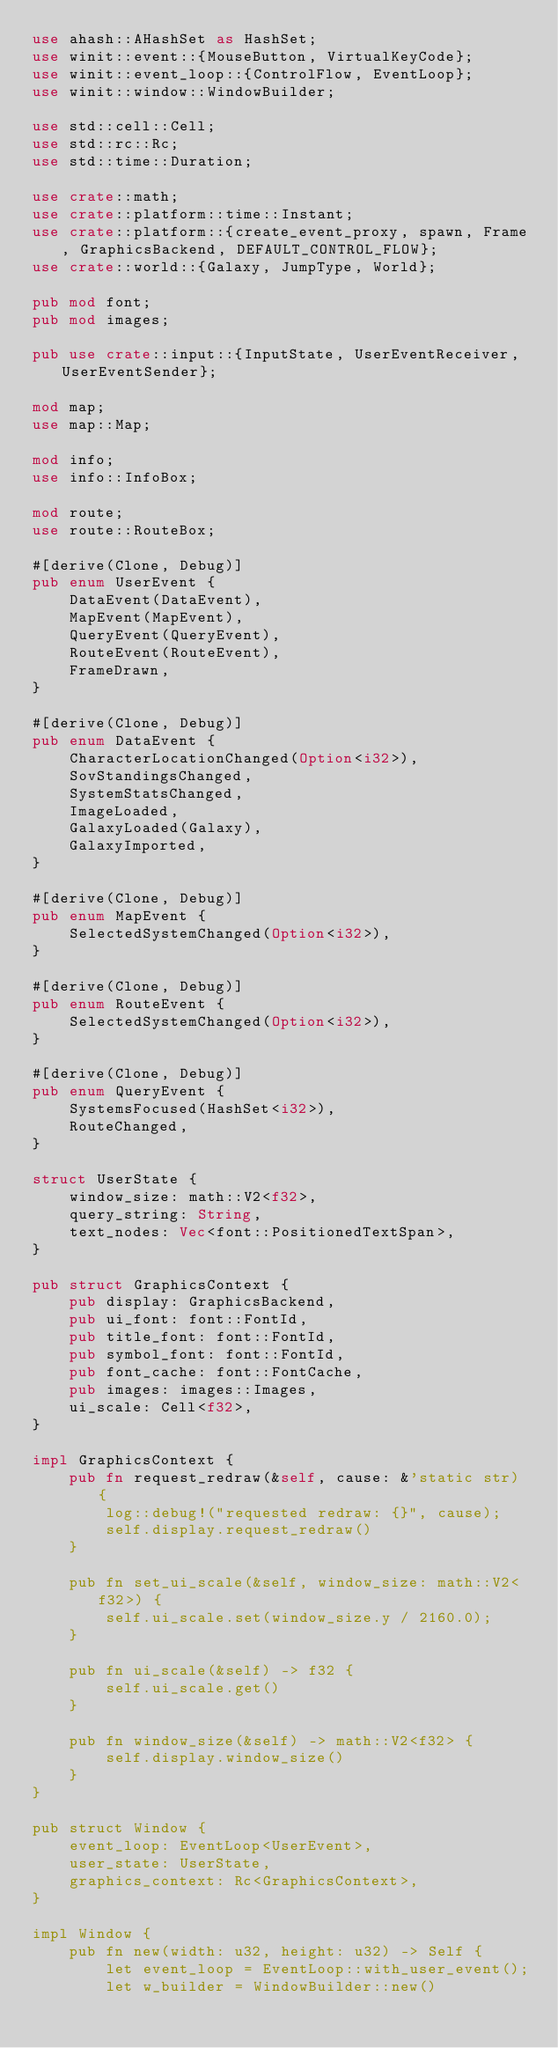Convert code to text. <code><loc_0><loc_0><loc_500><loc_500><_Rust_>use ahash::AHashSet as HashSet;
use winit::event::{MouseButton, VirtualKeyCode};
use winit::event_loop::{ControlFlow, EventLoop};
use winit::window::WindowBuilder;

use std::cell::Cell;
use std::rc::Rc;
use std::time::Duration;

use crate::math;
use crate::platform::time::Instant;
use crate::platform::{create_event_proxy, spawn, Frame, GraphicsBackend, DEFAULT_CONTROL_FLOW};
use crate::world::{Galaxy, JumpType, World};

pub mod font;
pub mod images;

pub use crate::input::{InputState, UserEventReceiver, UserEventSender};

mod map;
use map::Map;

mod info;
use info::InfoBox;

mod route;
use route::RouteBox;

#[derive(Clone, Debug)]
pub enum UserEvent {
    DataEvent(DataEvent),
    MapEvent(MapEvent),
    QueryEvent(QueryEvent),
    RouteEvent(RouteEvent),
    FrameDrawn,
}

#[derive(Clone, Debug)]
pub enum DataEvent {
    CharacterLocationChanged(Option<i32>),
    SovStandingsChanged,
    SystemStatsChanged,
    ImageLoaded,
    GalaxyLoaded(Galaxy),
    GalaxyImported,
}

#[derive(Clone, Debug)]
pub enum MapEvent {
    SelectedSystemChanged(Option<i32>),
}

#[derive(Clone, Debug)]
pub enum RouteEvent {
    SelectedSystemChanged(Option<i32>),
}

#[derive(Clone, Debug)]
pub enum QueryEvent {
    SystemsFocused(HashSet<i32>),
    RouteChanged,
}

struct UserState {
    window_size: math::V2<f32>,
    query_string: String,
    text_nodes: Vec<font::PositionedTextSpan>,
}

pub struct GraphicsContext {
    pub display: GraphicsBackend,
    pub ui_font: font::FontId,
    pub title_font: font::FontId,
    pub symbol_font: font::FontId,
    pub font_cache: font::FontCache,
    pub images: images::Images,
    ui_scale: Cell<f32>,
}

impl GraphicsContext {
    pub fn request_redraw(&self, cause: &'static str) {
        log::debug!("requested redraw: {}", cause);
        self.display.request_redraw()
    }

    pub fn set_ui_scale(&self, window_size: math::V2<f32>) {
        self.ui_scale.set(window_size.y / 2160.0);
    }

    pub fn ui_scale(&self) -> f32 {
        self.ui_scale.get()
    }

    pub fn window_size(&self) -> math::V2<f32> {
        self.display.window_size()
    }
}

pub struct Window {
    event_loop: EventLoop<UserEvent>,
    user_state: UserState,
    graphics_context: Rc<GraphicsContext>,
}

impl Window {
    pub fn new(width: u32, height: u32) -> Self {
        let event_loop = EventLoop::with_user_event();
        let w_builder = WindowBuilder::new()</code> 